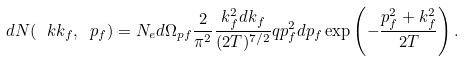<formula> <loc_0><loc_0><loc_500><loc_500>d N ( \ k k _ { f } , \ p _ { f } ) = N _ { e } d \Omega _ { p f } \frac { 2 } { \pi ^ { 2 } } \frac { k ^ { 2 } _ { f } d k _ { f } } { ( 2 T ) ^ { 7 / 2 } } q p ^ { 2 } _ { f } d p _ { f } \exp \left ( - \frac { p _ { f } ^ { 2 } + k _ { f } ^ { 2 } } { 2 T } \right ) .</formula> 